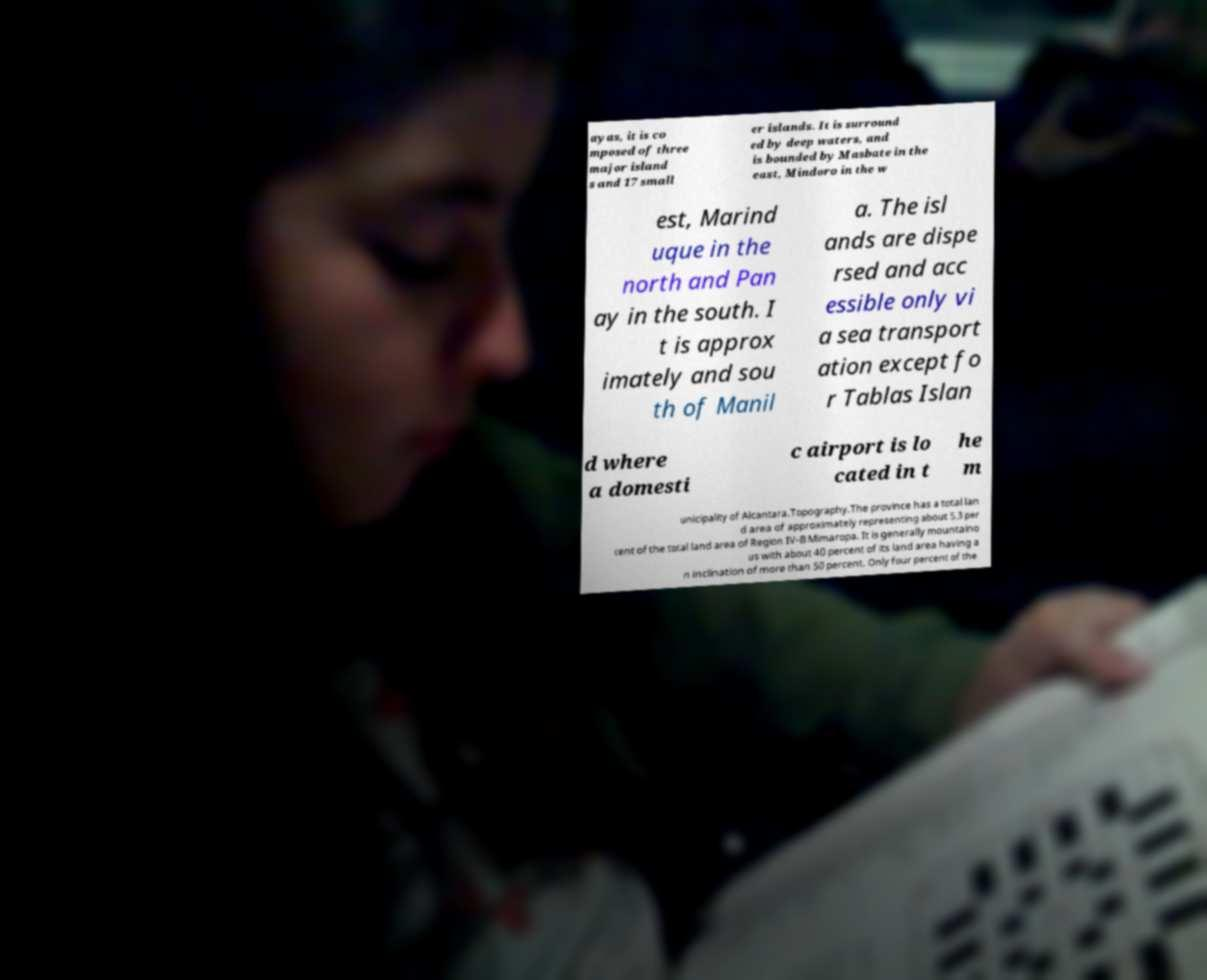Could you extract and type out the text from this image? ayas, it is co mposed of three major island s and 17 small er islands. It is surround ed by deep waters, and is bounded by Masbate in the east, Mindoro in the w est, Marind uque in the north and Pan ay in the south. I t is approx imately and sou th of Manil a. The isl ands are dispe rsed and acc essible only vi a sea transport ation except fo r Tablas Islan d where a domesti c airport is lo cated in t he m unicipality of Alcantara.Topography.The province has a total lan d area of approximately representing about 5.3 per cent of the total land area of Region IV-B Mimaropa. It is generally mountaino us with about 40 percent of its land area having a n inclination of more than 50 percent. Only four percent of the 